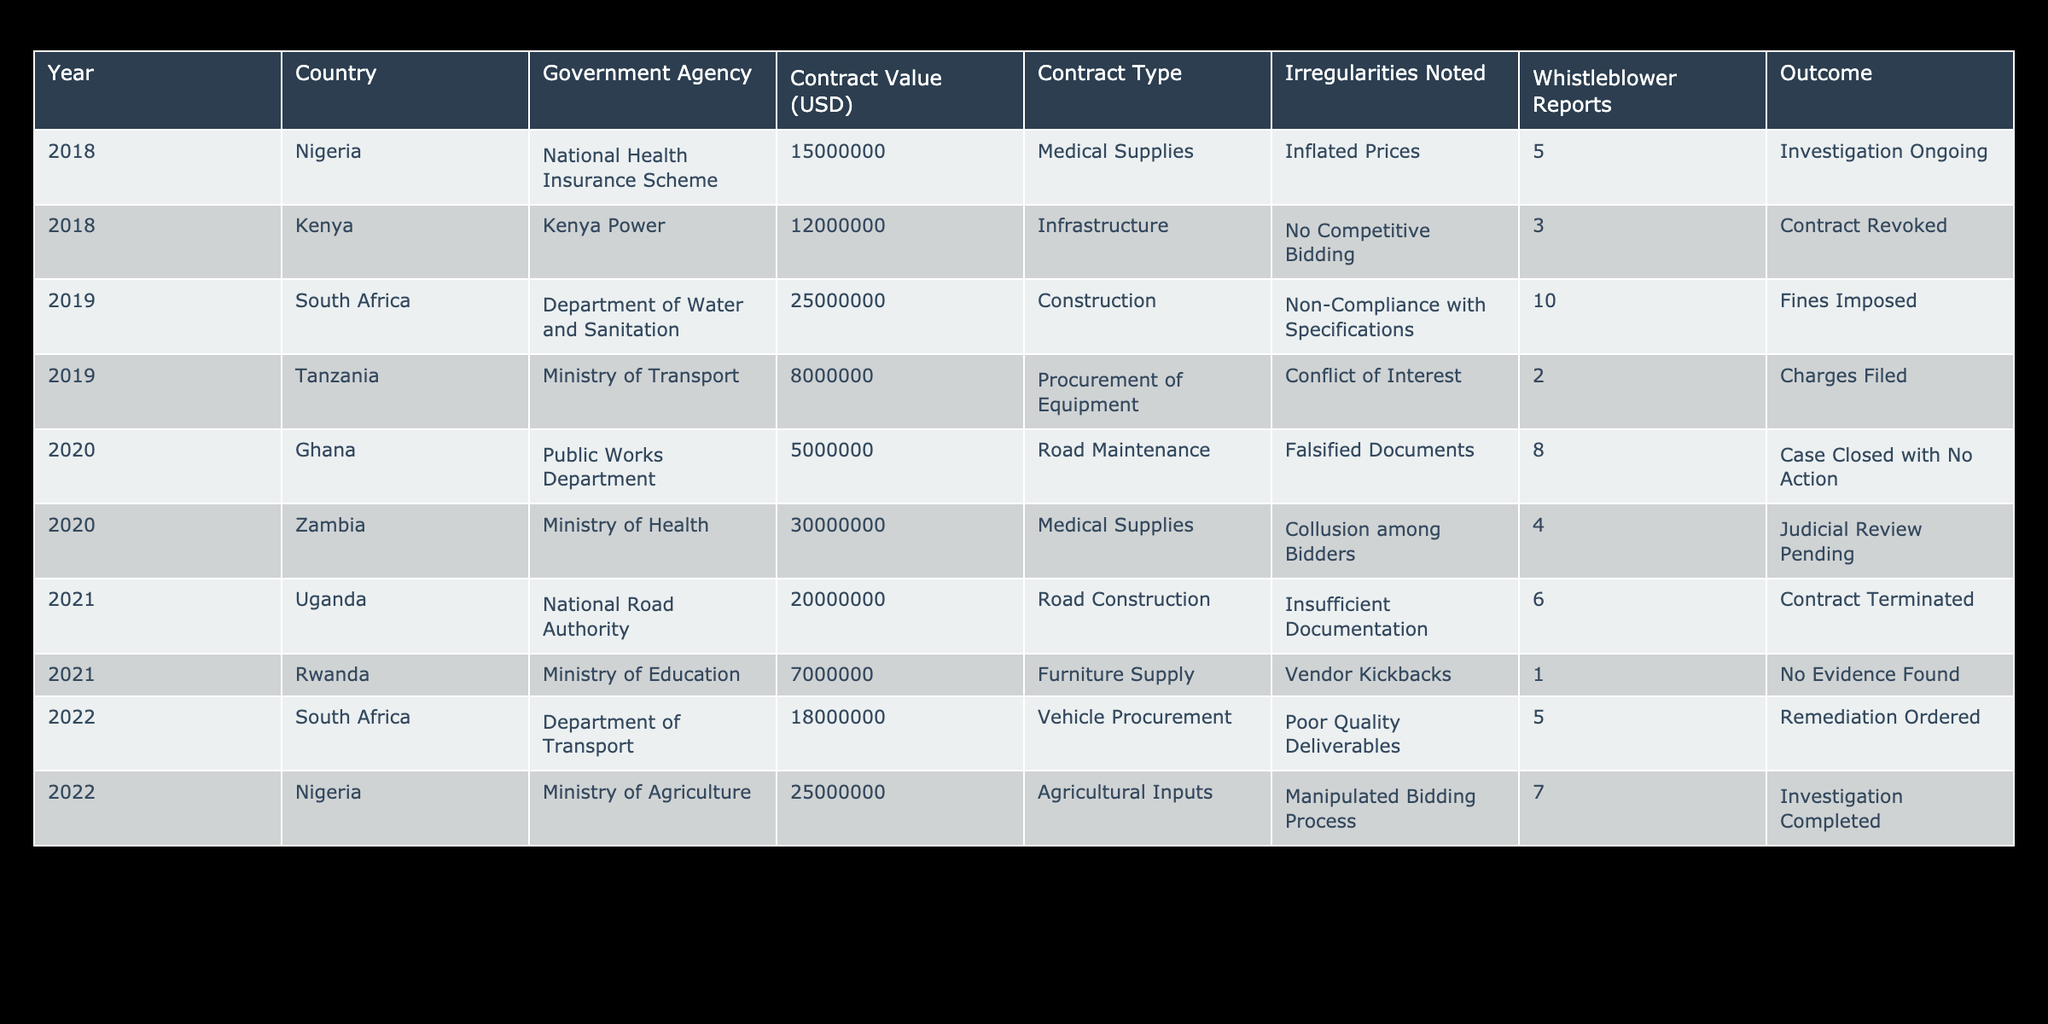What was the highest contract value noted in the table? The highest contract value is associated with the Department of Water and Sanitation in South Africa for 25000000 USD in 2019. Looking through the "Contract Value (USD)" column, I can confirm that it's the largest amount listed, as I check each entry.
Answer: 25000000 USD How many contracts in total noted irregularities during the year 2020? In 2020, I can see two entries in the table: one for Ghana with "Falsified Documents" and one for Zambia with "Collusion among Bidders". Therefore, the total number of contracts with irregularities noted is 2.
Answer: 2 Did the Ministry of Agriculture in Nigeria have any ongoing investigations in the table? According to the data, the outcome for the Ministry of Agriculture in Nigeria shows "Investigation Completed," which indicates no ongoing investigations. Hence, the answer is no.
Answer: No Which country had the most whistleblower reports in 2019, and how many were there? The data shows that, in 2019, the Department of Water and Sanitation in South Africa had the highest whistleblower reports at 10. I have compared the entries and confirmed this number is greater than any other noted in that year.
Answer: South Africa, 10 What is the average contract value of all entries noted for Nigeria? Nigeria has two entries with contract values of 15000000 USD in 2018 and 25000000 USD in 2022. To find the average, I sum these values (15000000 + 25000000 = 40000000 USD) and divide by the number of entries (2), resulting in an average of 20000000 USD.
Answer: 20000000 USD Did any contracts note "No Competitive Bidding"? The table indicates that Kenya Power noted "No Competitive Bidding" in 2018. This fact confirms that at least one contract recorded this irregularity.
Answer: Yes Which agency experienced a contract termination in 2021, and for what reason? The National Road Authority in Uganda experienced a contract termination in 2021 due to "Insufficient Documentation," as listed in the table. I checked the year and the relevant column to confirm this specific detail.
Answer: National Road Authority, Insufficient Documentation What is the total number of whistleblower reports associated with medical supply contracts across all years? For the contracts related to medical supplies in Nigeria (2018) with 5 whistleblower reports and Zambia (2020) with 4 reports, I add them together. The total is 5 + 4 = 9 whistleblower reports.
Answer: 9 